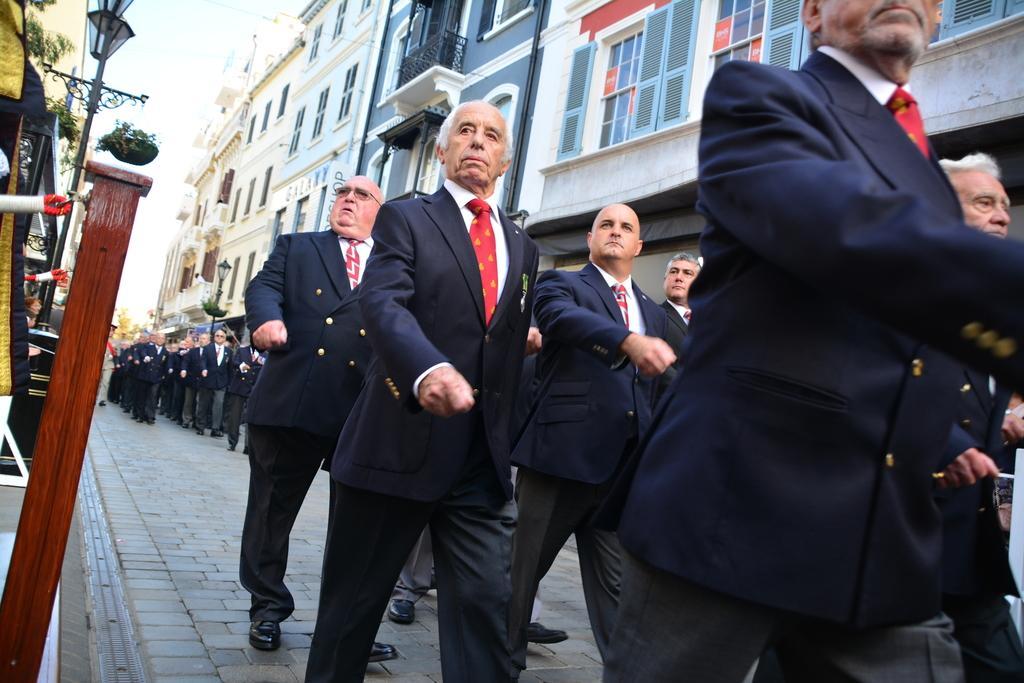Please provide a concise description of this image. In this picture there are men in the center of the image, those who are walking in series and there are buildings at the top side of the image. 